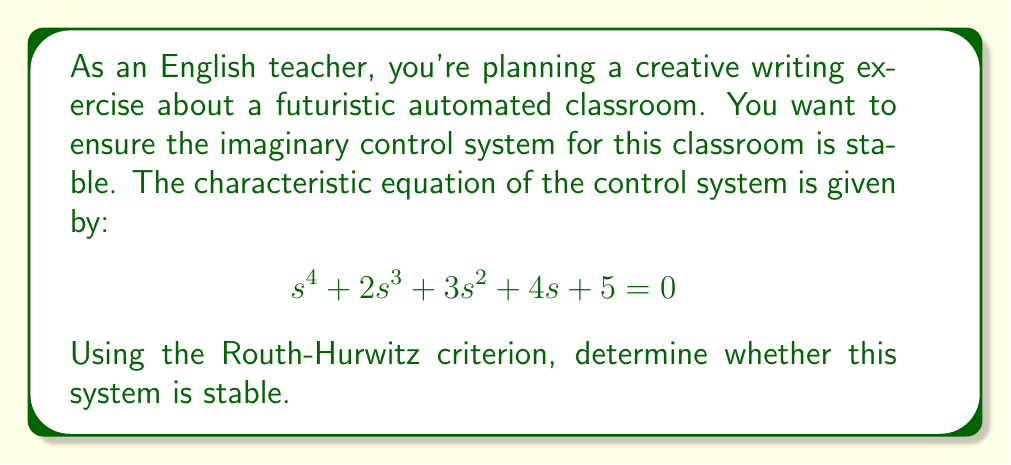Give your solution to this math problem. To determine the stability of the system using the Routh-Hurwitz criterion, we need to construct the Routh array and analyze it. Here's the step-by-step process:

1. Construct the Routh array:

   $$\begin{array}{c|cccc}
   s^4 & 1 & 3 & 5 \\
   s^3 & 2 & 4 & 0 \\
   s^2 & b_1 & b_2 & \\
   s^1 & c_1 & \\
   s^0 & d_1 &
   \end{array}$$

2. Calculate the values for the remaining rows:

   For $s^2$ row:
   $$b_1 = \frac{(2)(3) - (1)(4)}{2} = 1$$
   $$b_2 = \frac{(2)(5) - (1)(0)}{2} = 5$$

   For $s^1$ row:
   $$c_1 = \frac{(1)(4) - (2)(5)}{1} = -6$$

   For $s^0$ row:
   $$d_1 = 5$$ (as $b_2 = 5$)

3. The complete Routh array:

   $$\begin{array}{c|cccc}
   s^4 & 1 & 3 & 5 \\
   s^3 & 2 & 4 & 0 \\
   s^2 & 1 & 5 & \\
   s^1 & -6 & \\
   s^0 & 5 &
   \end{array}$$

4. Analyze the first column of the Routh array:
   According to the Routh-Hurwitz criterion, the system is stable if and only if all the elements in the first column of the Routh array have the same sign (all positive or all negative).

   In this case, we see a sign change in the first column (from positive to negative and back to positive), which indicates instability.
Answer: The system is unstable because there is a sign change in the first column of the Routh array. 